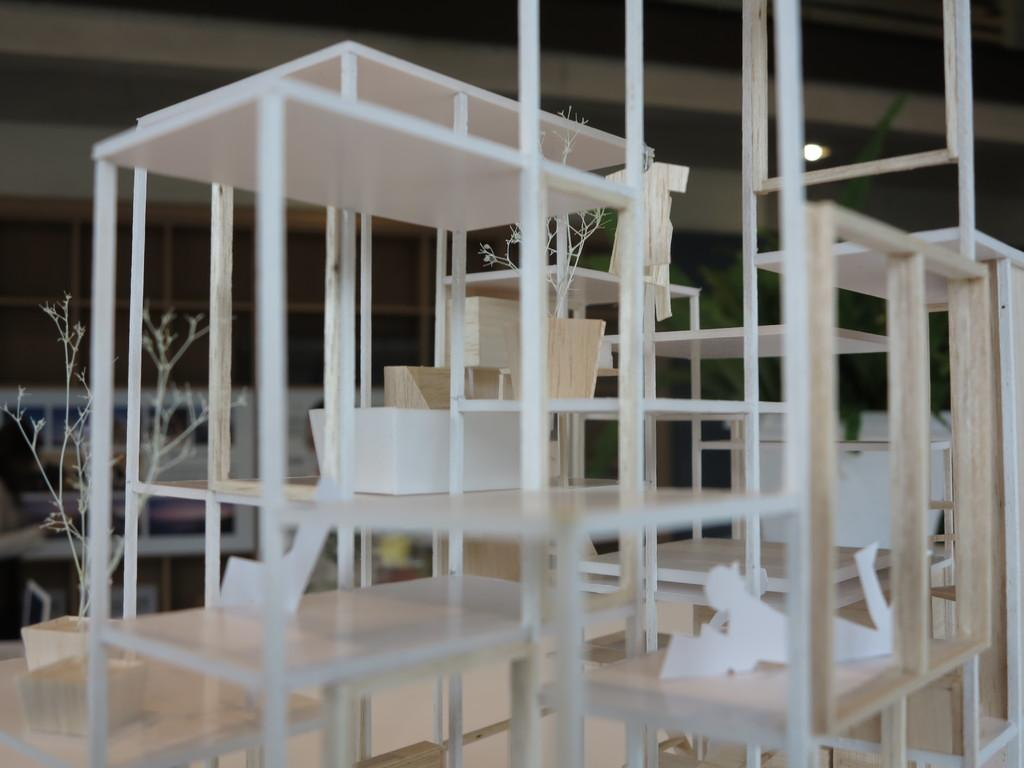Where was the image taken? The image was clicked indoors. What can be seen in the middle of the image? There are pots and tables in the middle of the image. What is inside the pots? There are plants in the pots. Can you see a knot tied on any of the plants in the image? There is no knot present on any of the plants in the image. What type of leaf can be seen on the plants in the image? The image does not provide enough detail to identify the specific type of leaf on the plants. 